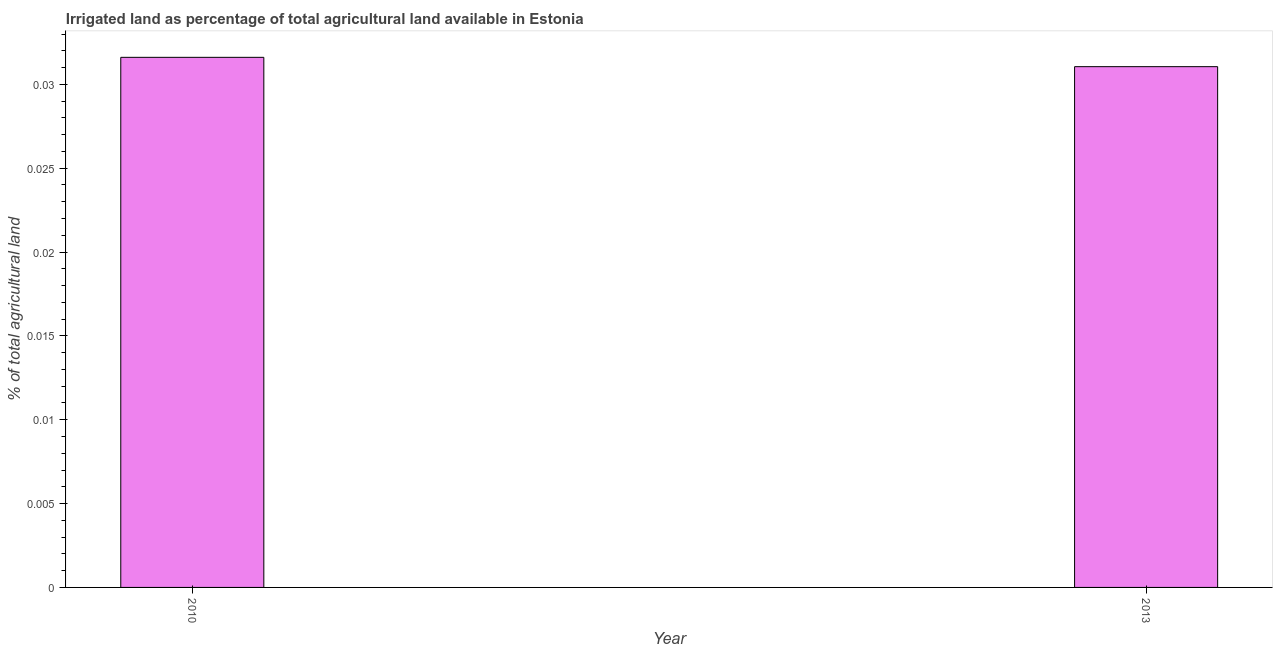Does the graph contain grids?
Your answer should be very brief. No. What is the title of the graph?
Your answer should be compact. Irrigated land as percentage of total agricultural land available in Estonia. What is the label or title of the Y-axis?
Ensure brevity in your answer.  % of total agricultural land. What is the percentage of agricultural irrigated land in 2013?
Keep it short and to the point. 0.03. Across all years, what is the maximum percentage of agricultural irrigated land?
Keep it short and to the point. 0.03. Across all years, what is the minimum percentage of agricultural irrigated land?
Keep it short and to the point. 0.03. In which year was the percentage of agricultural irrigated land minimum?
Keep it short and to the point. 2013. What is the sum of the percentage of agricultural irrigated land?
Offer a terse response. 0.06. What is the difference between the percentage of agricultural irrigated land in 2010 and 2013?
Provide a short and direct response. 0. What is the average percentage of agricultural irrigated land per year?
Your answer should be compact. 0.03. What is the median percentage of agricultural irrigated land?
Your response must be concise. 0.03. In how many years, is the percentage of agricultural irrigated land greater than 0.01 %?
Offer a very short reply. 2. What is the ratio of the percentage of agricultural irrigated land in 2010 to that in 2013?
Make the answer very short. 1.02. How many bars are there?
Your answer should be very brief. 2. What is the difference between two consecutive major ticks on the Y-axis?
Provide a short and direct response. 0.01. Are the values on the major ticks of Y-axis written in scientific E-notation?
Offer a terse response. No. What is the % of total agricultural land in 2010?
Provide a succinct answer. 0.03. What is the % of total agricultural land in 2013?
Keep it short and to the point. 0.03. What is the difference between the % of total agricultural land in 2010 and 2013?
Keep it short and to the point. 0. 